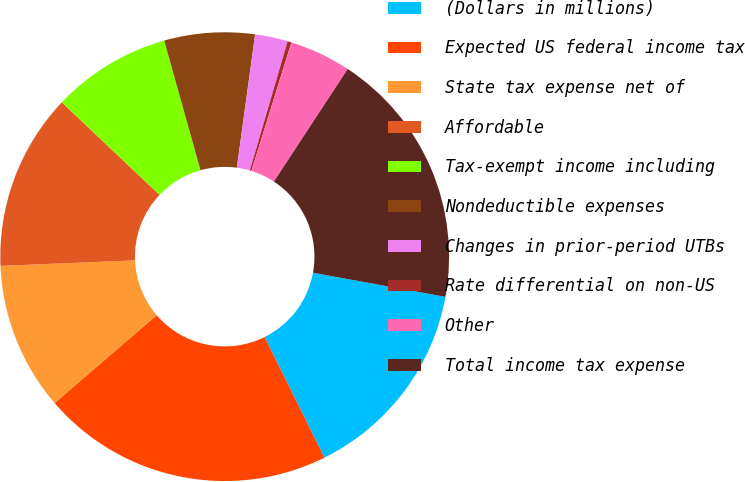Convert chart to OTSL. <chart><loc_0><loc_0><loc_500><loc_500><pie_chart><fcel>(Dollars in millions)<fcel>Expected US federal income tax<fcel>State tax expense net of<fcel>Affordable<fcel>Tax-exempt income including<fcel>Nondeductible expenses<fcel>Changes in prior-period UTBs<fcel>Rate differential on non-US<fcel>Other<fcel>Total income tax expense<nl><fcel>14.8%<fcel>21.02%<fcel>10.65%<fcel>12.73%<fcel>8.58%<fcel>6.51%<fcel>2.36%<fcel>0.28%<fcel>4.43%<fcel>18.63%<nl></chart> 